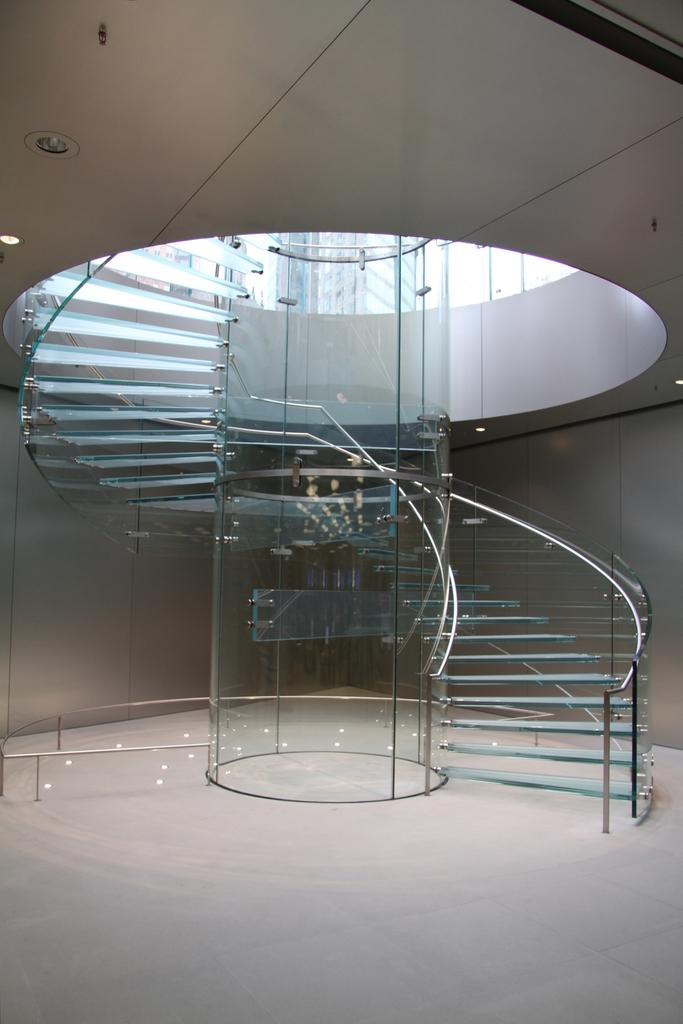What type of staircase is depicted in the image? The staircase in the image is made of glass. Is there any safety feature around the glass staircase? Yes, there is a railing around the staircase. What can be seen near the staircase in the image? Lights are attached to the ceiling near the staircase. What type of silk material is draped over the railing of the staircase in the image? There is no silk material present on the railing of the staircase in the image. What attraction is located near the staircase in the image? The image does not show any specific attraction near the staircase. 